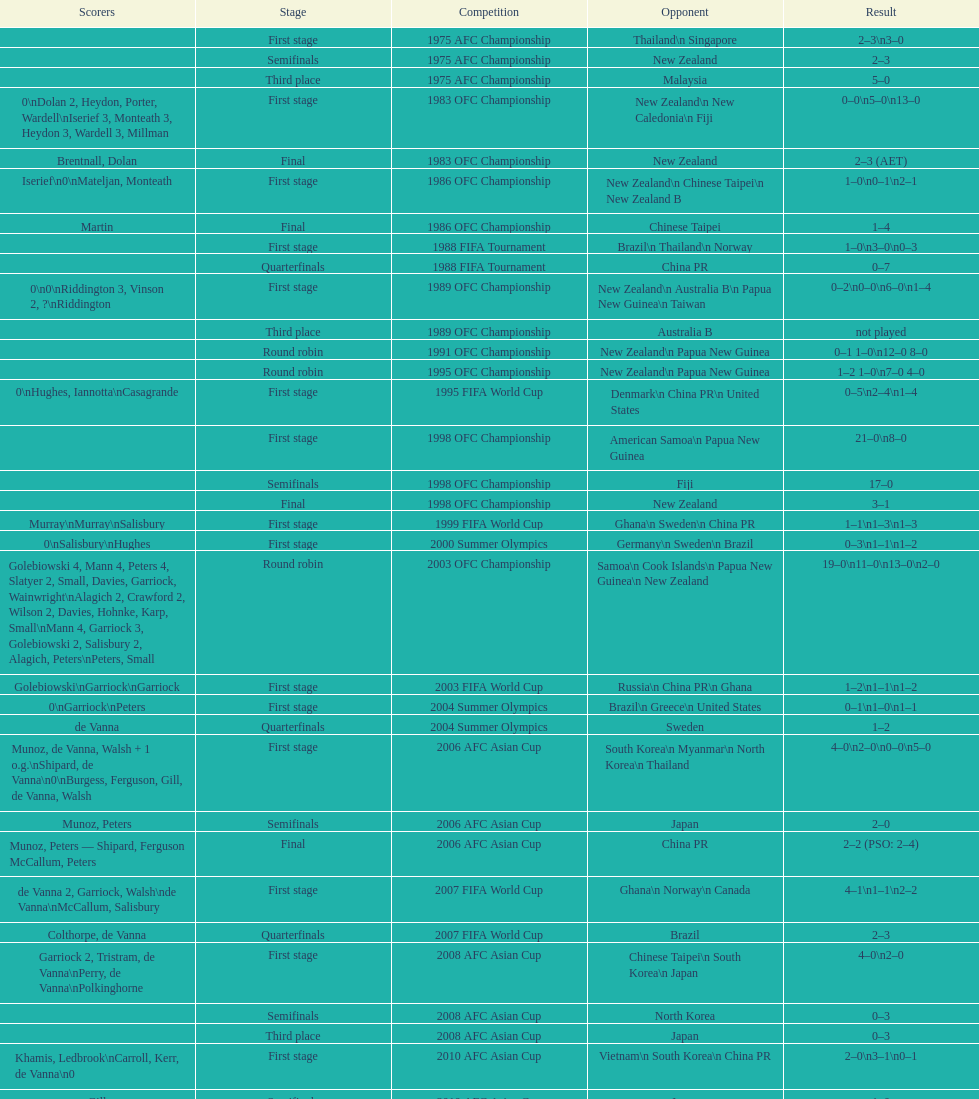Who was the last opponent this team faced in the 2010 afc asian cup? North Korea. 